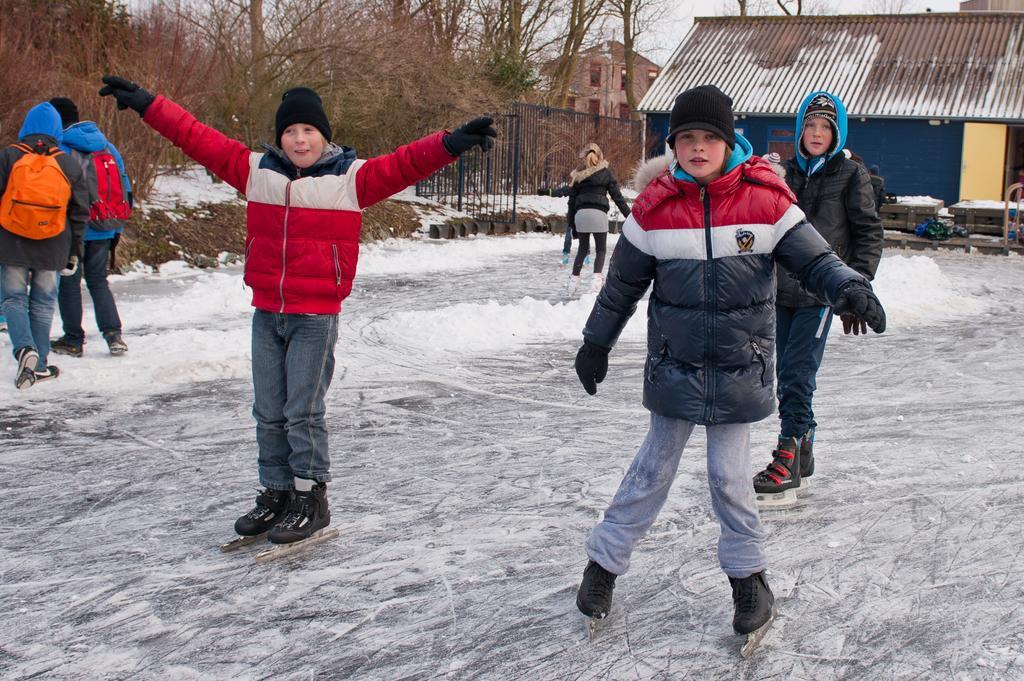How would you summarize this image in a sentence or two? In the middle a boy is doing skating, he wore coat, cap. On the left side few other people are also doing skating on the snow. On the right side there is an iron shed. 